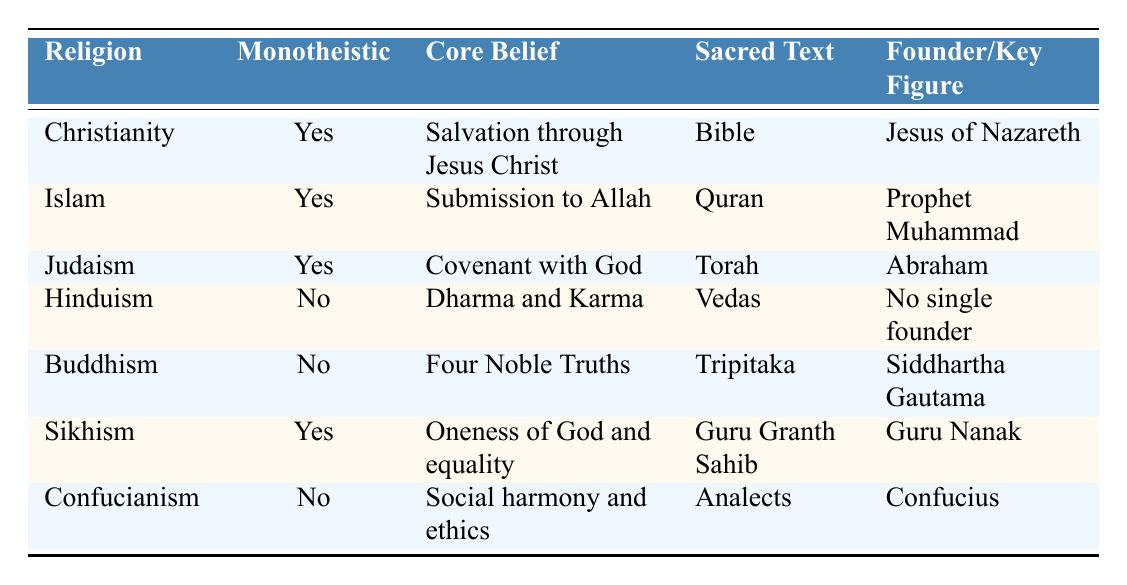What is the core belief of Islam? The core belief of Islam, as stated in the table, is "Submission to Allah." This information can be directly found in the corresponding row for Islam.
Answer: Submission to Allah Which religions are monotheistic? To identify the monotheistic religions, we can look at the "Monotheistic" column. The religions marked as "Yes" are Christianity, Islam, Judaism, and Sikhism. This information is gathered from filtering the rows based on this column.
Answer: Christianity, Islam, Judaism, Sikhism How many religions in the table have a single founder? Analyzing the "Founder/Key Figure" column, I see that only Christianity, Islam, Judaism, Buddhism, and Sikhism have listed founders. However, Hinduism states "No single founder," and Confucianism states "Confucius," indicating he is a founding figure. Thus, there are six entries concerning unique founders, minus Hinduism.
Answer: 5 Is Buddhism a monotheistic religion? According to the table, Buddhism is marked as "No" under the "Monotheistic" column, which indicates that it does not adhere to the belief in a single divine entity.
Answer: No Which religion's sacred text is the Vedas? By examining the "Sacred Text" column, it is clear that "Vedas" corresponds to Hinduism. Thus, the answer can be reached simply by looking at the sacred texts listed for each religion.
Answer: Hinduism How many religions teach the importance of ethical behavior and social harmony? Referring to the "Core Belief" column, we see that Confucianism emphasizes "Social harmony and ethics." No other religion listed directly highlights social harmony. Therefore, Confucianism is the only one that focuses on this principle.
Answer: 1 What is the core belief of Sikhism, and how does it differ from that of Christianity? Sikhism's core belief is "Oneness of God and equality," while Christianity's core belief is "Salvation through Jesus Christ." The differences can be noted in that Sikhism focuses more on equality and unity, while Christianity centers on salvation through faith in Jesus. This comparison involves examining the respective rows for each religion's core belief.
Answer: Oneness of God and equality; differs by focus on equality vs. salvation through Jesus Which sacred text is associated with Judaism? Looking at the "Sacred Text" column, "Torah" is listed under the "Judaism" row, indicating it is the sacred text associated with this religion. The information is directly retrievable from the table.
Answer: Torah 